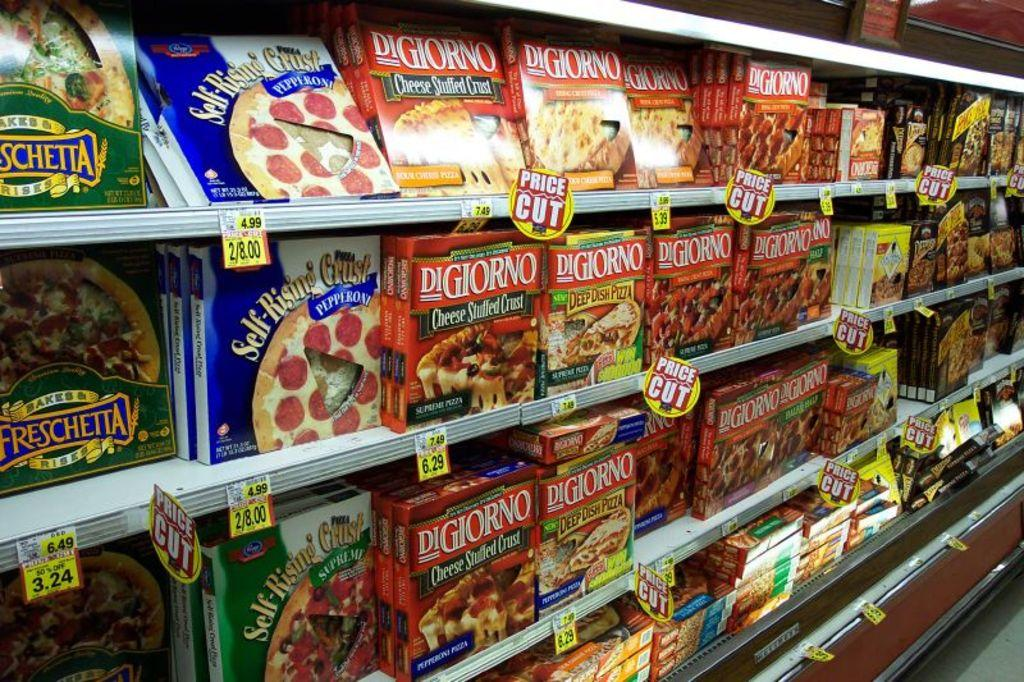<image>
Write a terse but informative summary of the picture. A selection of frozen pizzas includes some from DiGiorno. 